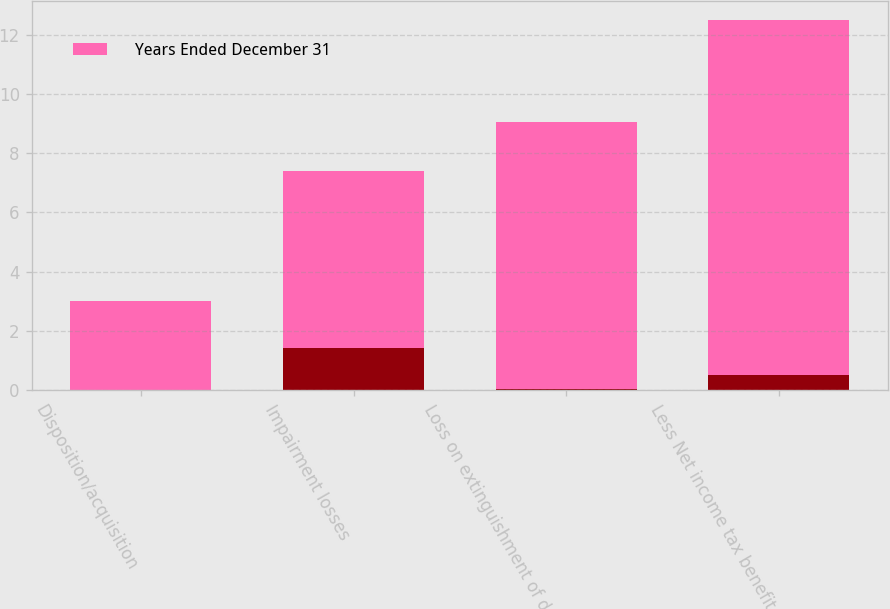Convert chart. <chart><loc_0><loc_0><loc_500><loc_500><stacked_bar_chart><ecel><fcel>Disposition/acquisition<fcel>Impairment losses<fcel>Loss on extinguishment of debt<fcel>Less Net income tax benefit<nl><fcel>nan<fcel>0.01<fcel>1.41<fcel>0.05<fcel>0.51<nl><fcel>Years Ended December 31<fcel>3<fcel>6<fcel>9<fcel>12<nl></chart> 